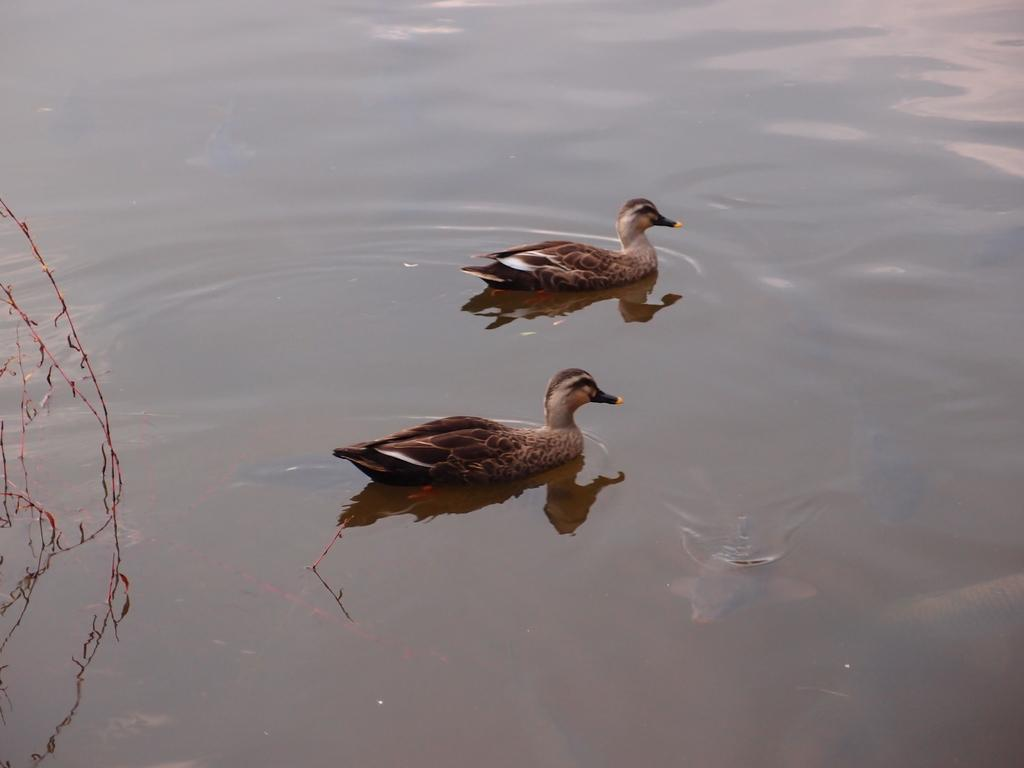How many ducks are in the image? There are two ducks in the image. What are the ducks doing in the image? The ducks are swimming in the water. Can you describe the water in the image? The water might be in a pond. What can be seen on the left side of the image? There are plants on the left side of the image. What type of island can be seen in the image? There is no island present in the image; it features two ducks swimming in water with plants on the left side. 